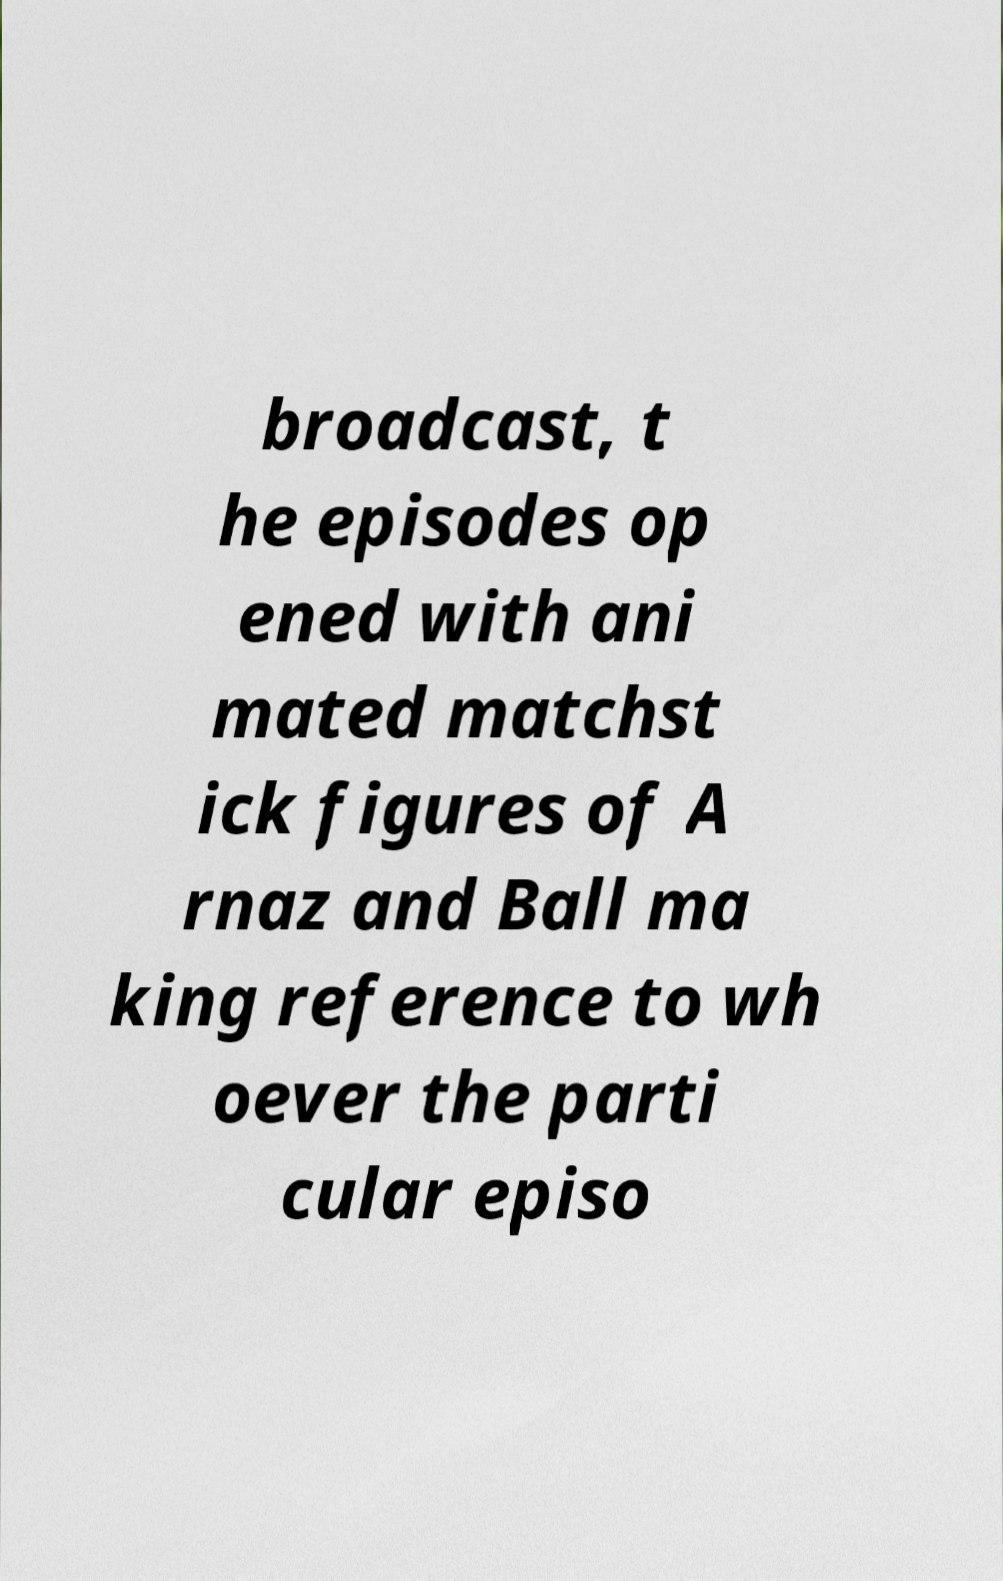Can you read and provide the text displayed in the image?This photo seems to have some interesting text. Can you extract and type it out for me? broadcast, t he episodes op ened with ani mated matchst ick figures of A rnaz and Ball ma king reference to wh oever the parti cular episo 